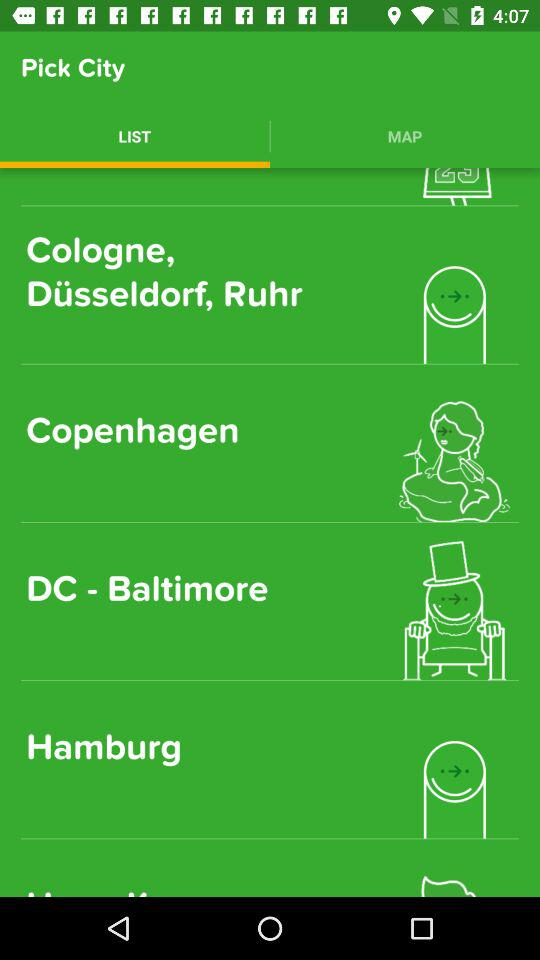Which tab is selected? The selected tab is "LIST". 